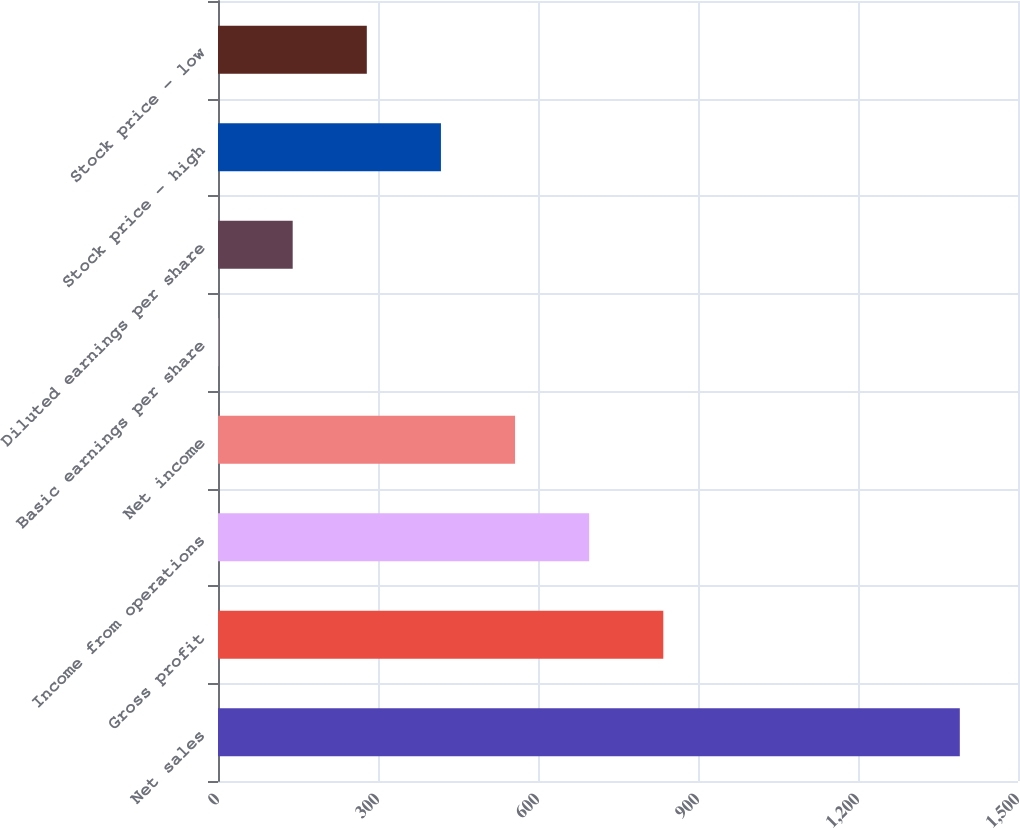Convert chart to OTSL. <chart><loc_0><loc_0><loc_500><loc_500><bar_chart><fcel>Net sales<fcel>Gross profit<fcel>Income from operations<fcel>Net income<fcel>Basic earnings per share<fcel>Diluted earnings per share<fcel>Stock price - high<fcel>Stock price - low<nl><fcel>1390.9<fcel>834.95<fcel>695.97<fcel>556.99<fcel>1.07<fcel>140.05<fcel>418.01<fcel>279.03<nl></chart> 